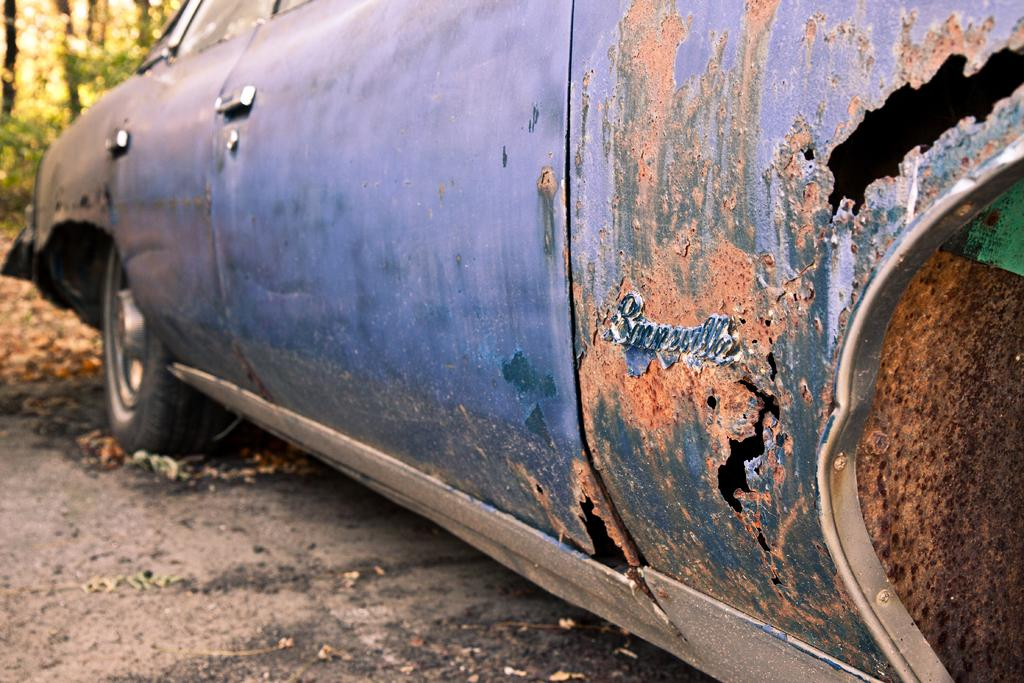What type of vehicle is in the image? There is an old car in the image. Where is the car located? The car is on the road. What can be seen in the background of the image? There are trees in the background of the image. How does the car aid in the digestion process in the image? The car does not aid in the digestion process in the image; it is a vehicle and not related to digestion. 